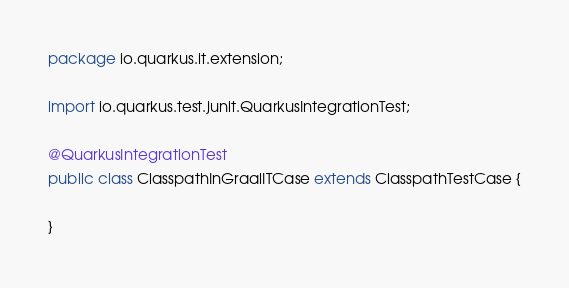Convert code to text. <code><loc_0><loc_0><loc_500><loc_500><_Java_>package io.quarkus.it.extension;

import io.quarkus.test.junit.QuarkusIntegrationTest;

@QuarkusIntegrationTest
public class ClasspathInGraalITCase extends ClasspathTestCase {

}
</code> 